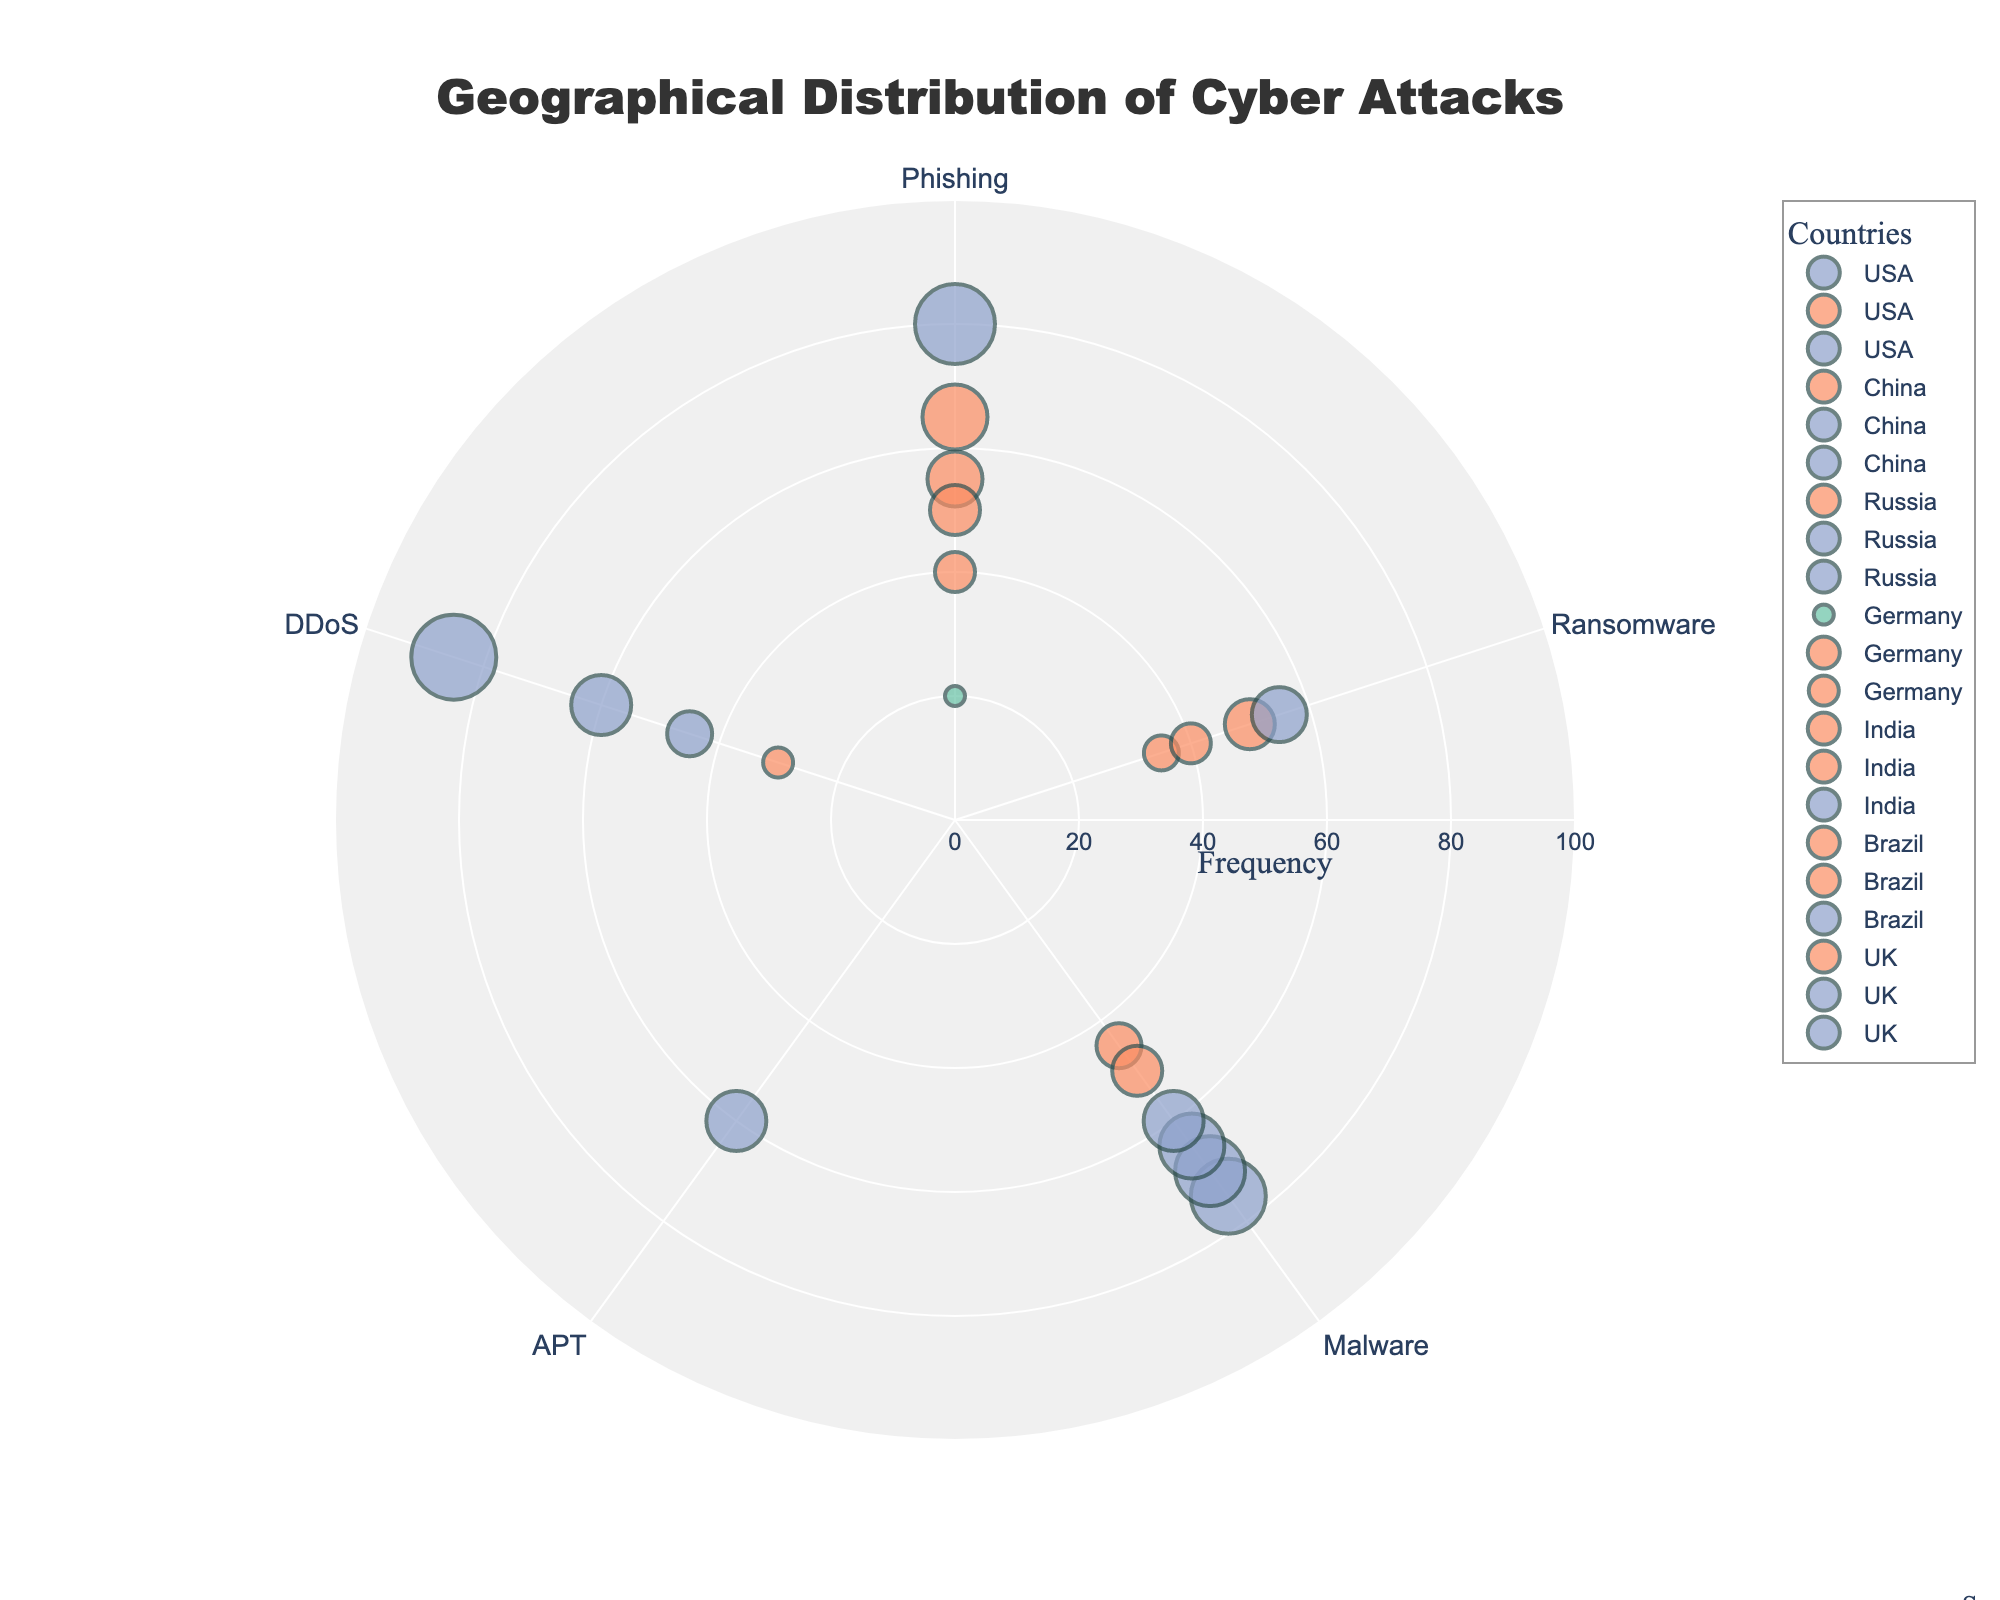What is the title of the figure? The title is the large text at the top of the figure, written in darker, bold letters to stand out.
Answer: Geographical Distribution of Cyber Attacks How many countries are represented in the chart? The chart has legend entries for each country, usually marked by distinct markers or colors. Count the number of unique country names in the legend.
Answer: 6 Which country has the highest frequency of cyber attacks for DDoS? Look for the country with the highest marker on the radial axis corresponding to the DDoS attack vector. Identify the highest frequency value and then find the associated country.
Answer: Russia How many different attack vectors are shown in the chart? Check the unique labels in the angular axis, which denote the attack vectors.
Answer: 5 Which attack vector in China has the highest severity level? Identify the attack vectors for China and check the color of their markers. The color indicates the severity level. High severity is typically shown in dark blue.
Answer: APT 